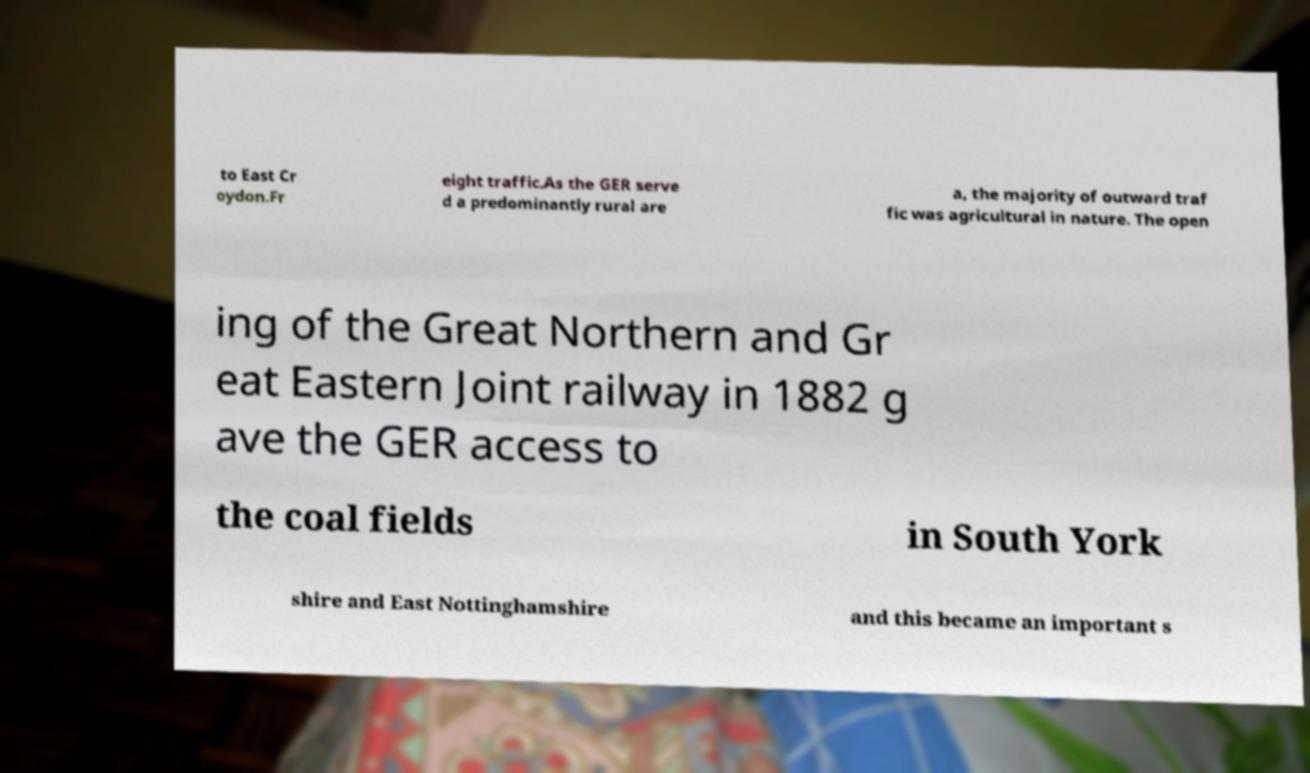Please identify and transcribe the text found in this image. to East Cr oydon.Fr eight traffic.As the GER serve d a predominantly rural are a, the majority of outward traf fic was agricultural in nature. The open ing of the Great Northern and Gr eat Eastern Joint railway in 1882 g ave the GER access to the coal fields in South York shire and East Nottinghamshire and this became an important s 